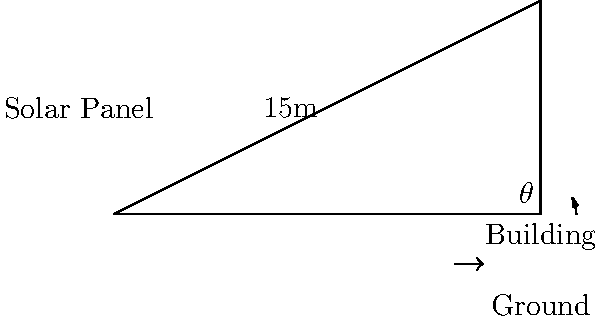As part of a community energy efficiency initiative in Strabane, you're tasked with installing solar panels on a local building. The roof has a length of 6 meters and rises to a height of 3 meters. If the optimal angle for solar panel efficiency is equal to the roof's pitch, what angle should the panels be installed at to maximize energy capture? Round your answer to the nearest degree. Let's approach this step-by-step:

1) We can see that the roof forms a right-angled triangle. We need to find the angle $\theta$ at the base of this triangle.

2) We know the opposite (height) and adjacent (length) sides of this triangle:
   - Opposite (height) = 3 meters
   - Adjacent (length) = 6 meters

3) To find the angle, we can use the tangent function:

   $$\tan(\theta) = \frac{\text{opposite}}{\text{adjacent}} = \frac{3}{6} = \frac{1}{2} = 0.5$$

4) To get the angle, we need to use the inverse tangent (arctan or $\tan^{-1}$):

   $$\theta = \tan^{-1}(0.5)$$

5) Using a calculator or trigonometric tables:

   $$\theta \approx 26.57°$$

6) Rounding to the nearest degree:

   $$\theta \approx 27°$$

Therefore, the solar panels should be installed at an angle of 27° to maximize energy capture.
Answer: 27° 